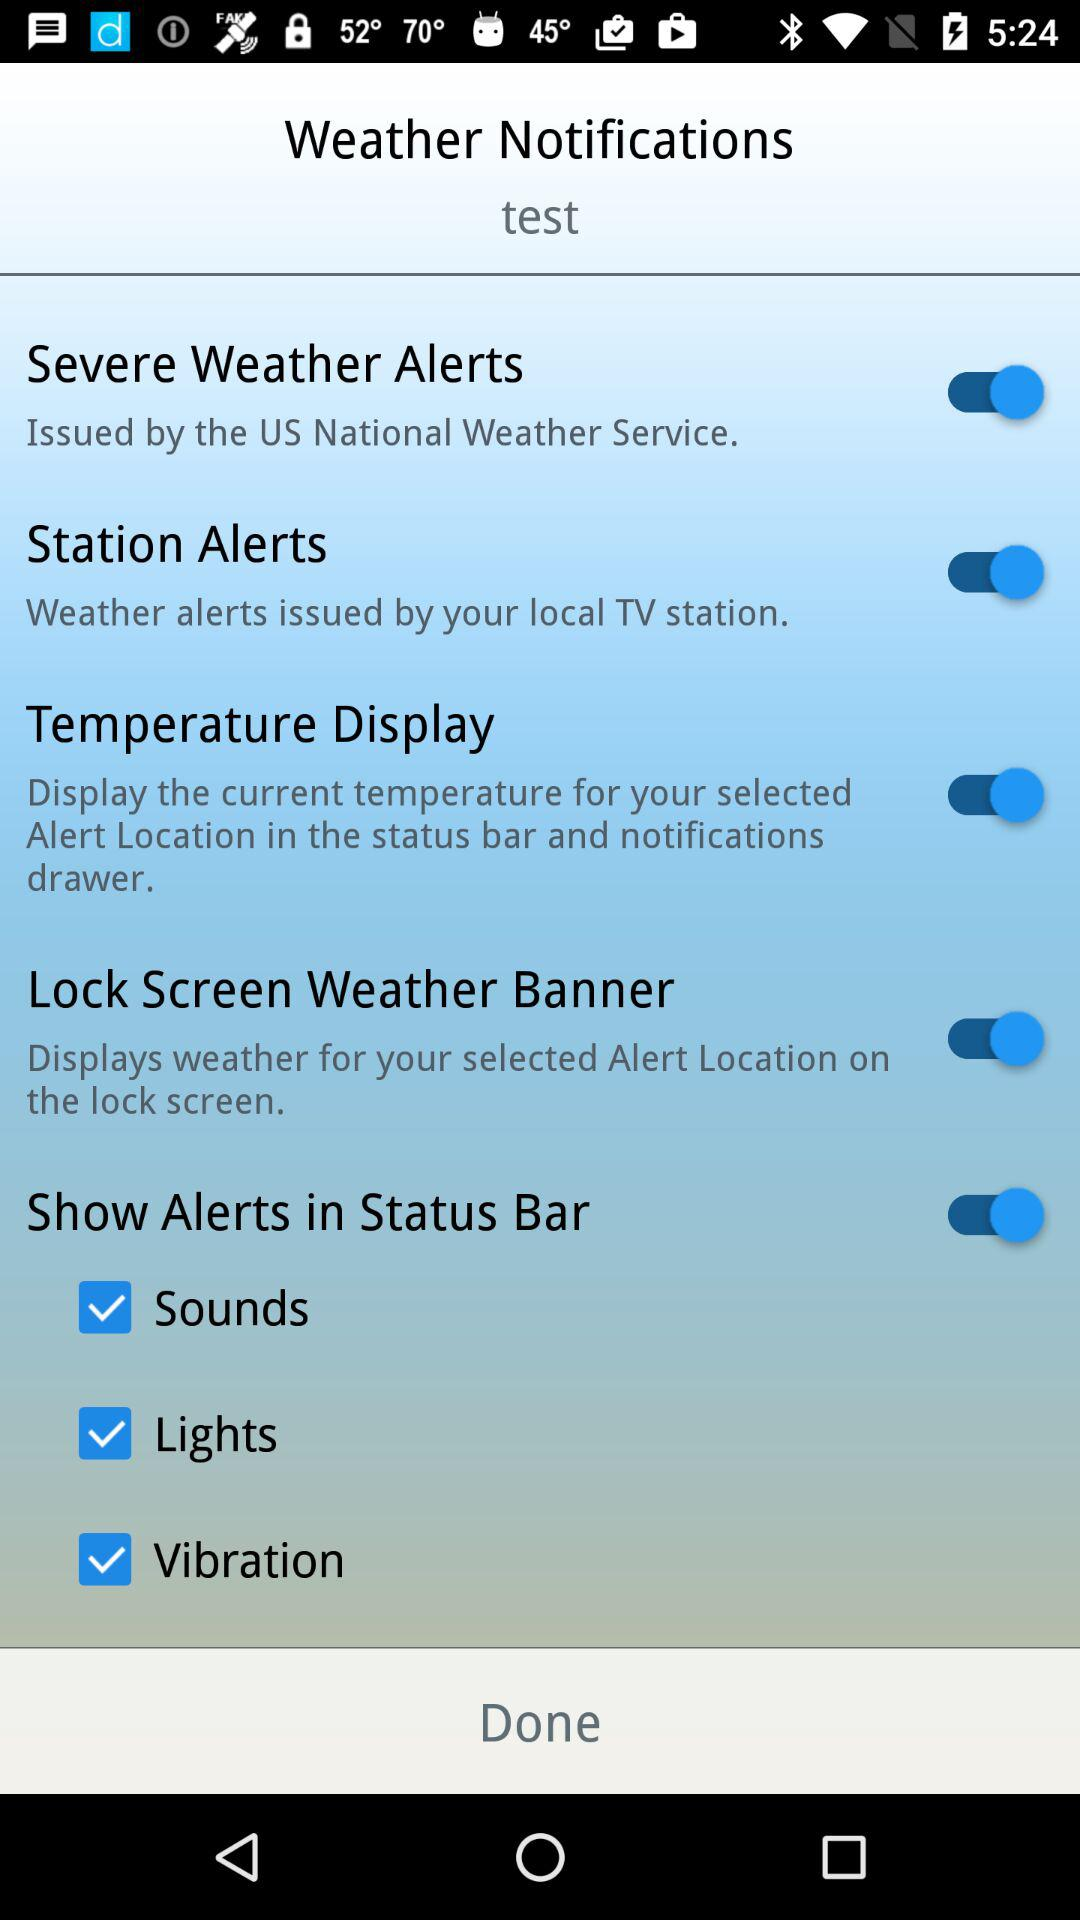What is the current status of the "Temperature Display"? The current status is "on". 